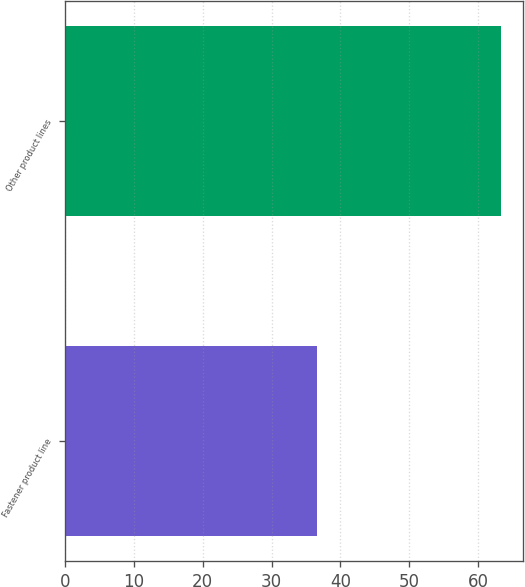Convert chart to OTSL. <chart><loc_0><loc_0><loc_500><loc_500><bar_chart><fcel>Fastener product line<fcel>Other product lines<nl><fcel>36.6<fcel>63.4<nl></chart> 